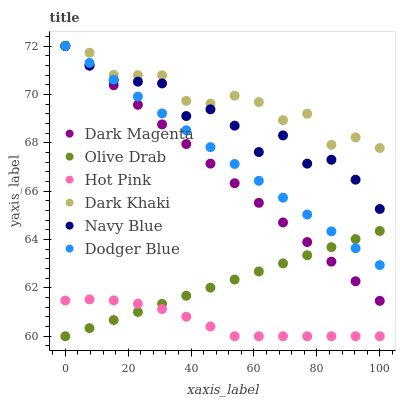Does Hot Pink have the minimum area under the curve?
Answer yes or no. Yes. Does Dark Khaki have the maximum area under the curve?
Answer yes or no. Yes. Does Navy Blue have the minimum area under the curve?
Answer yes or no. No. Does Navy Blue have the maximum area under the curve?
Answer yes or no. No. Is Dodger Blue the smoothest?
Answer yes or no. Yes. Is Navy Blue the roughest?
Answer yes or no. Yes. Is Hot Pink the smoothest?
Answer yes or no. No. Is Hot Pink the roughest?
Answer yes or no. No. Does Hot Pink have the lowest value?
Answer yes or no. Yes. Does Navy Blue have the lowest value?
Answer yes or no. No. Does Dodger Blue have the highest value?
Answer yes or no. Yes. Does Hot Pink have the highest value?
Answer yes or no. No. Is Hot Pink less than Navy Blue?
Answer yes or no. Yes. Is Dark Magenta greater than Hot Pink?
Answer yes or no. Yes. Does Olive Drab intersect Dodger Blue?
Answer yes or no. Yes. Is Olive Drab less than Dodger Blue?
Answer yes or no. No. Is Olive Drab greater than Dodger Blue?
Answer yes or no. No. Does Hot Pink intersect Navy Blue?
Answer yes or no. No. 